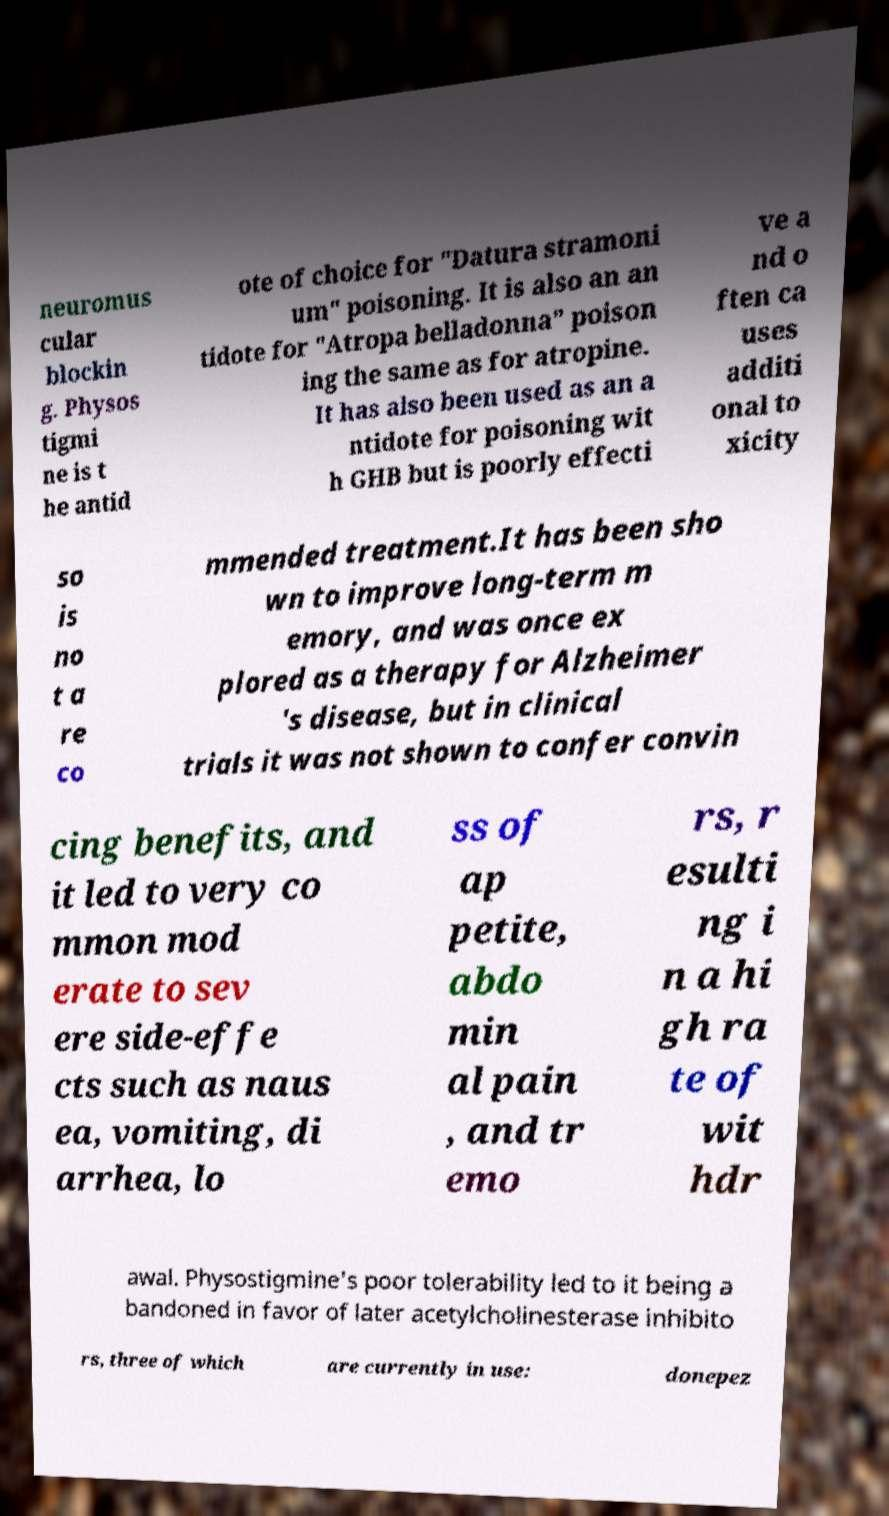I need the written content from this picture converted into text. Can you do that? neuromus cular blockin g. Physos tigmi ne is t he antid ote of choice for "Datura stramoni um" poisoning. It is also an an tidote for "Atropa belladonna" poison ing the same as for atropine. It has also been used as an a ntidote for poisoning wit h GHB but is poorly effecti ve a nd o ften ca uses additi onal to xicity so is no t a re co mmended treatment.It has been sho wn to improve long-term m emory, and was once ex plored as a therapy for Alzheimer 's disease, but in clinical trials it was not shown to confer convin cing benefits, and it led to very co mmon mod erate to sev ere side-effe cts such as naus ea, vomiting, di arrhea, lo ss of ap petite, abdo min al pain , and tr emo rs, r esulti ng i n a hi gh ra te of wit hdr awal. Physostigmine's poor tolerability led to it being a bandoned in favor of later acetylcholinesterase inhibito rs, three of which are currently in use: donepez 